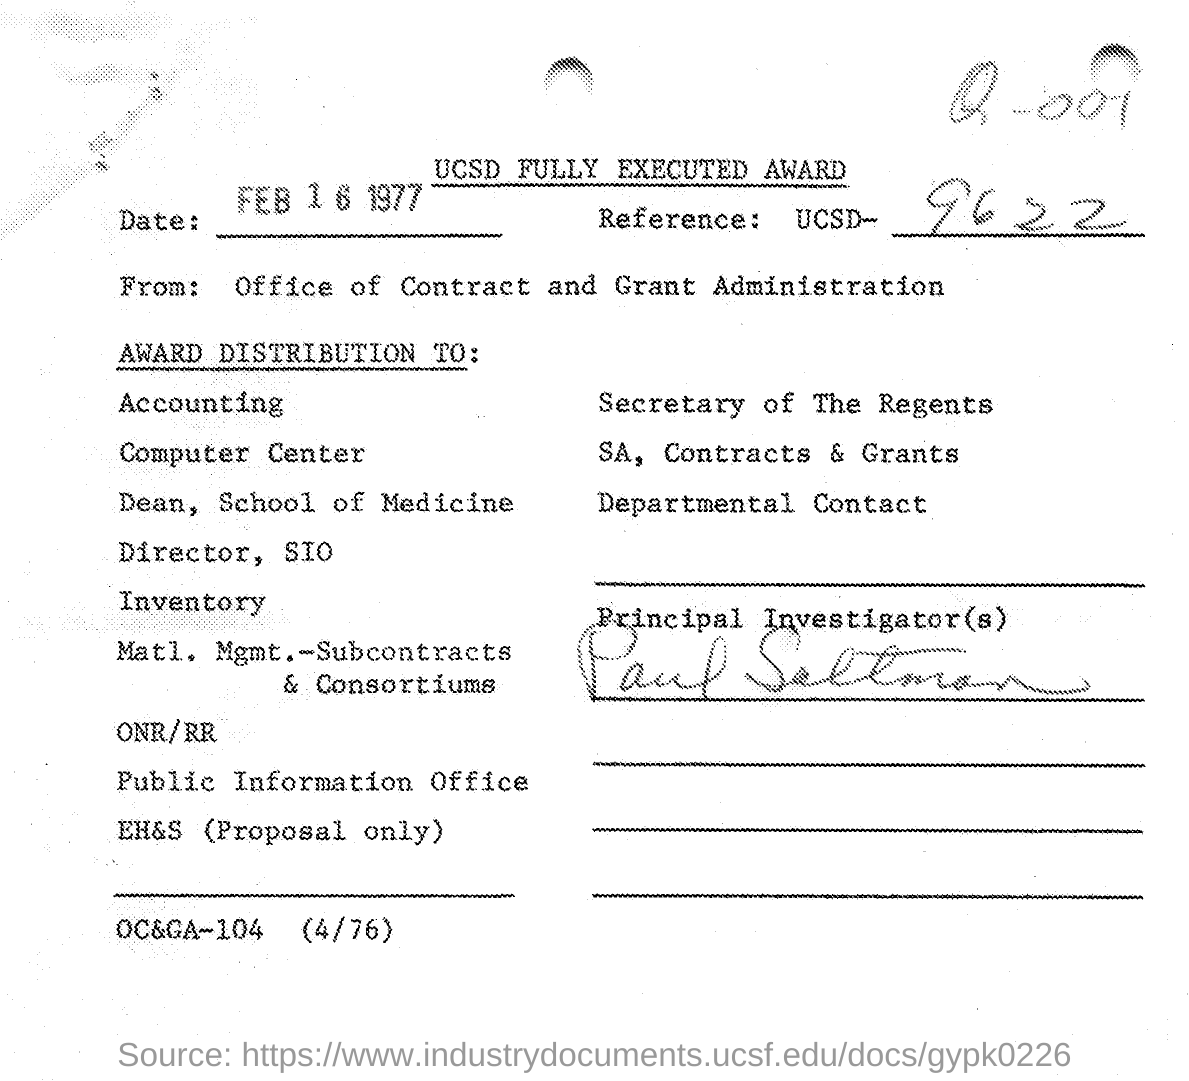What is the date mentioned in this document?
Your answer should be very brief. Feb 16 1977. What is the Reference given in this document?
Provide a short and direct response. UCSD - 9622. Who is the Principal Investigator?
Provide a succinct answer. Paul Saltman. 